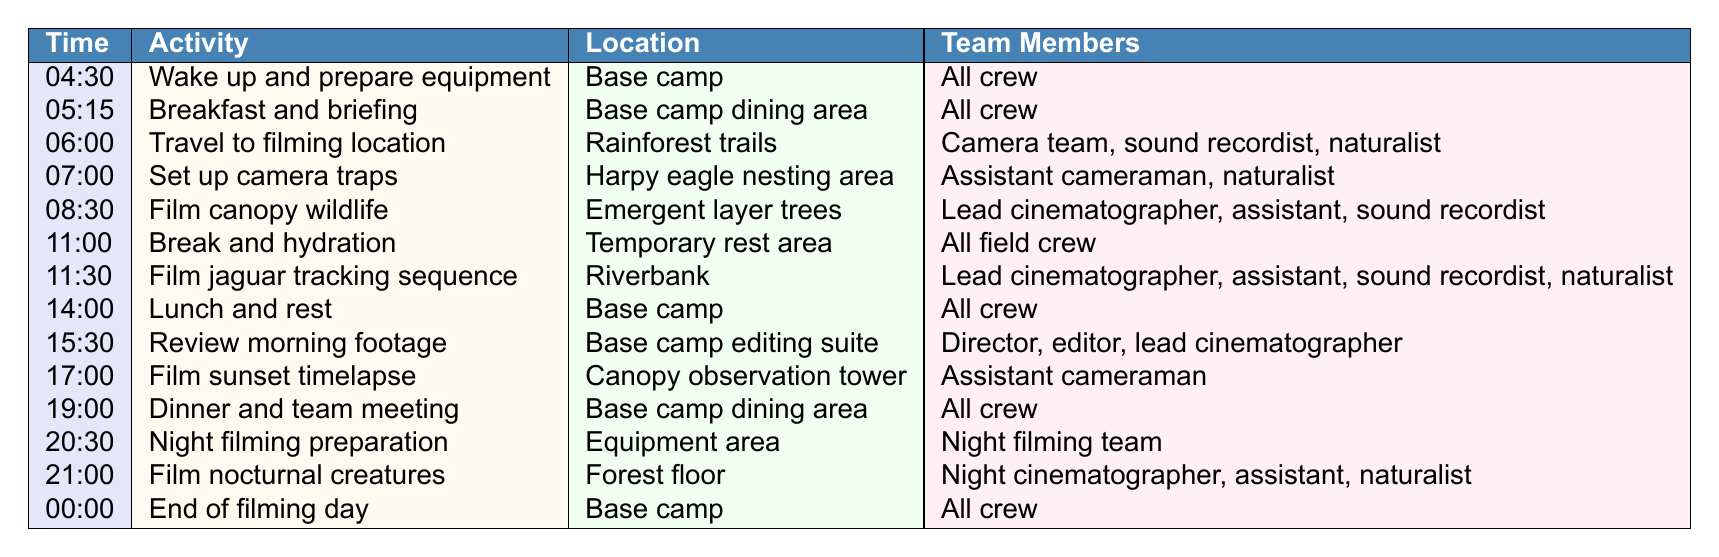What time does the crew have breakfast? The table lists breakfast and briefing as occurring at 05:15.
Answer: 05:15 How many activities are scheduled between 06:00 and 14:00? From the table, the activities between 06:00 and 14:00 are: Travel to filming location, Set up camera traps, Film canopy wildlife, Break and hydration, Film jaguar tracking sequence, and Lunch and rest. This counts up to six activities.
Answer: 6 Which activity requires the most crew members? The activity "Film jaguar tracking sequence" has the most crew members listed: Lead cinematographer, assistant, sound recordist, and naturalist, totaling four members.
Answer: Film jaguar tracking sequence Is there a break scheduled after lunch? After lunch at 14:00, the next scheduled activity at 15:30 is "Review morning footage." There is no break mentioned immediately after lunch.
Answer: No What are the two locations where the crew has meals? The crew has meals at "Base camp" for lunch, and at "Base camp dining area" for breakfast and dinner.
Answer: Base camp and Base camp dining area List the team members involved in the night filming preparation. The team members for "Night filming preparation" are the Night filming team, as mentioned in the table.
Answer: Night filming team How many activities take place after 19:00? After 19:00, there are two activities: "Night filming preparation" at 20:30 and "Film nocturnal creatures" at 21:00.
Answer: 2 At what time does the filming day end? The table indicates that the filming day ends at 00:00.
Answer: 00:00 How long is the total filming time during the day, excluding breaks and meals? The filming activities are from 06:00 to 19:00, and counting the activities gives us 10.5 hours of filming. However, since meals and breaks are excluded, we subtract those times, which leads to approximately 8.5 hours of active filming.
Answer: 8.5 hours Which member of the crew is responsible for the sunset timelapse? The "Assistant cameraman" is the only team member listed for the "Film sunset timelapse" activity at 17:00.
Answer: Assistant cameraman 